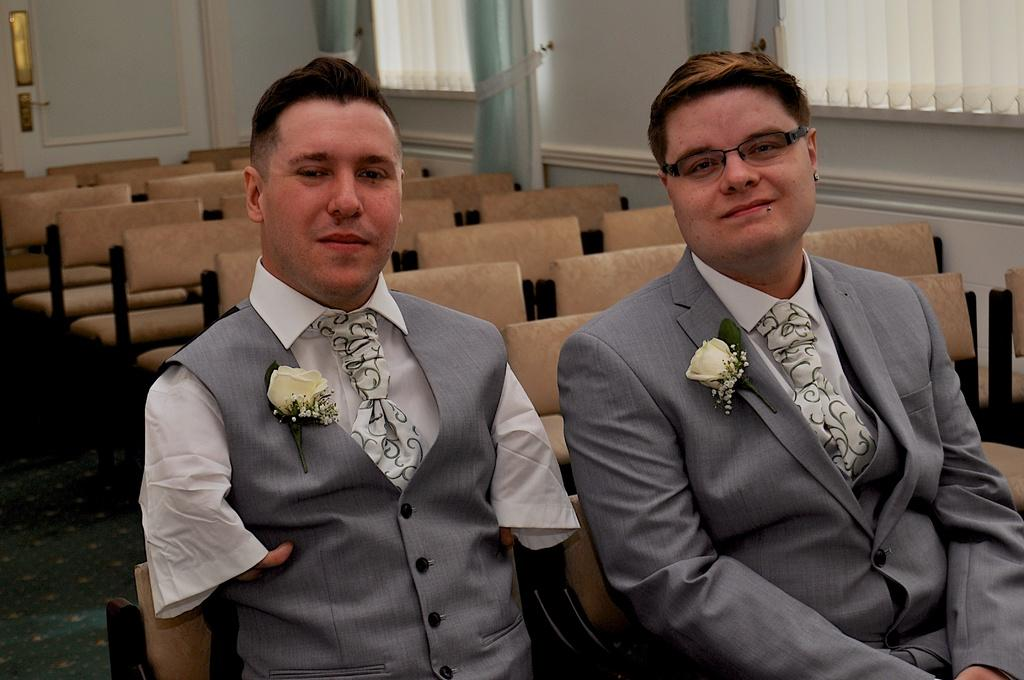What are the people in the image doing? The people in the image are sitting on chairs. How many chairs are visible in the image? There are both occupied and empty chairs in the image. Where are the empty chairs located in relation to the occupied chairs? The empty chairs are in the back. What can be seen on the windows in the image? There are blinds on the windows in the image. What type of ornament is hanging from the ceiling in the image? There is no ornament hanging from the ceiling in the image. What kind of insurance policy do the people in the image have? There is no information about insurance policies in the image. 